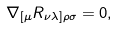<formula> <loc_0><loc_0><loc_500><loc_500>\nabla _ { [ \mu } R _ { \nu \lambda ] \rho \sigma } = 0 ,</formula> 